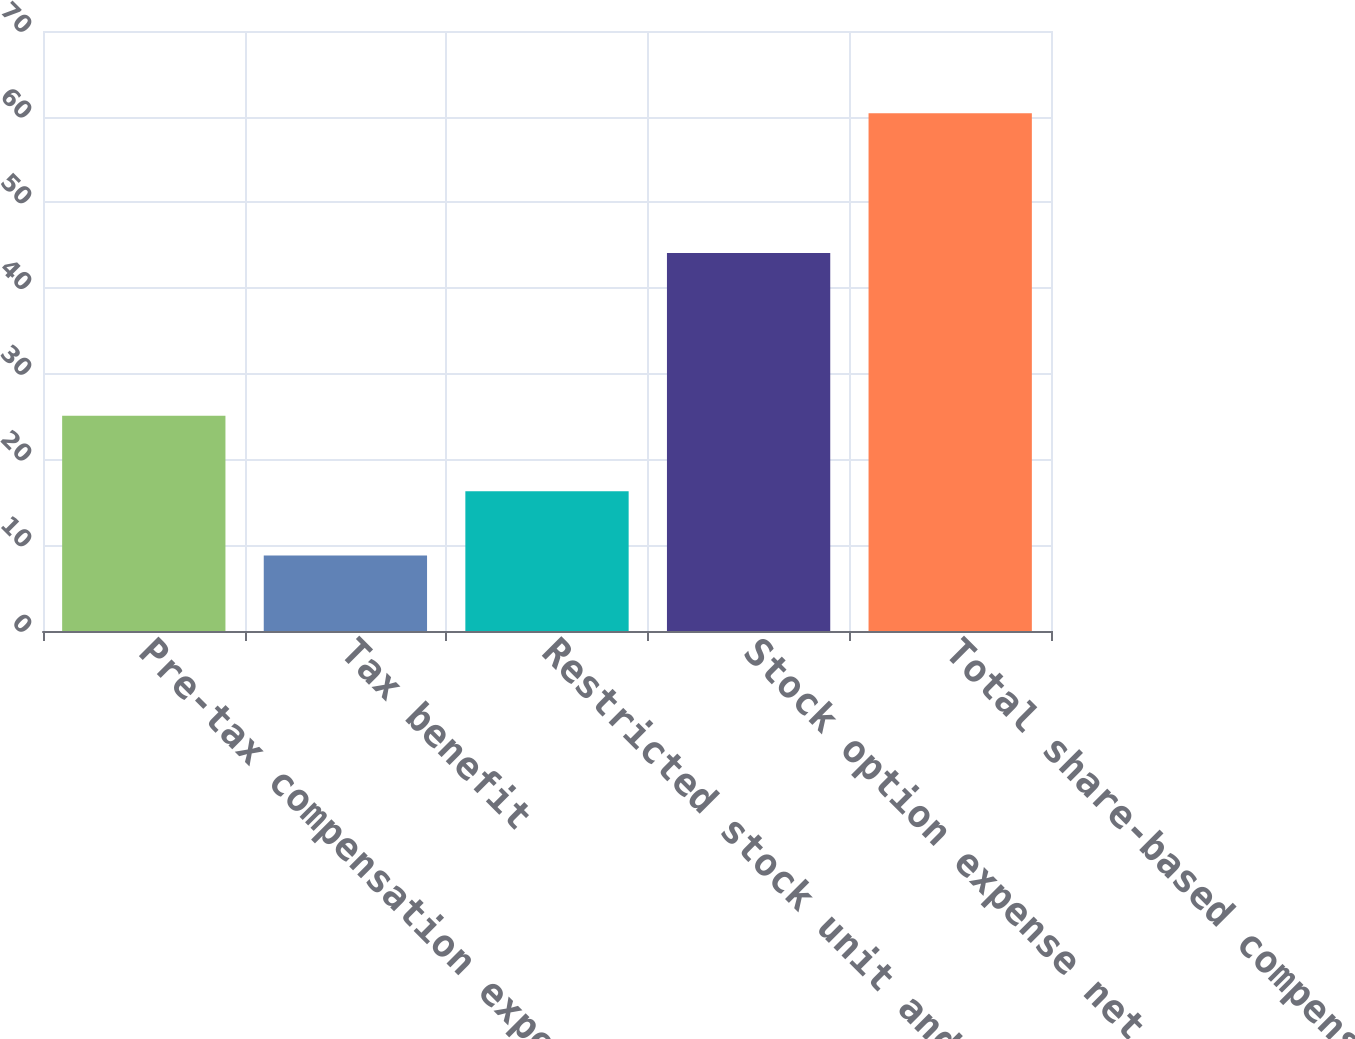Convert chart to OTSL. <chart><loc_0><loc_0><loc_500><loc_500><bar_chart><fcel>Pre-tax compensation expense<fcel>Tax benefit<fcel>Restricted stock unit and<fcel>Stock option expense net of<fcel>Total share-based compensation<nl><fcel>25.1<fcel>8.8<fcel>16.3<fcel>44.1<fcel>60.4<nl></chart> 